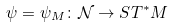Convert formula to latex. <formula><loc_0><loc_0><loc_500><loc_500>\psi = \psi _ { M } \colon \mathcal { N } \to S T ^ { * } M</formula> 